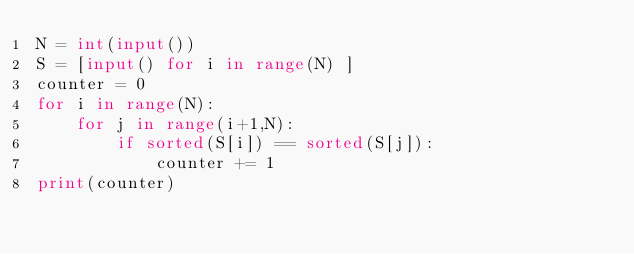<code> <loc_0><loc_0><loc_500><loc_500><_Python_>N = int(input())
S = [input() for i in range(N) ]
counter = 0
for i in range(N):
    for j in range(i+1,N):
        if sorted(S[i]) == sorted(S[j]):
            counter += 1
print(counter)</code> 